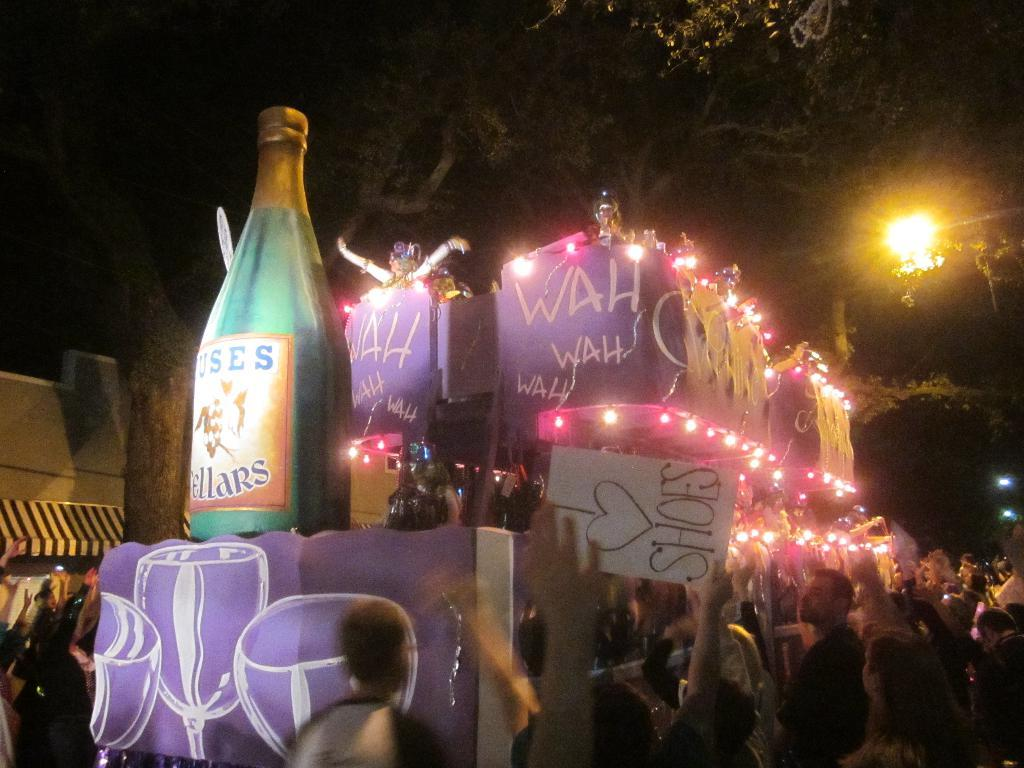Provide a one-sentence caption for the provided image. A crowd of people are celebrating an event and a big banner is shown with WAH WAH. 